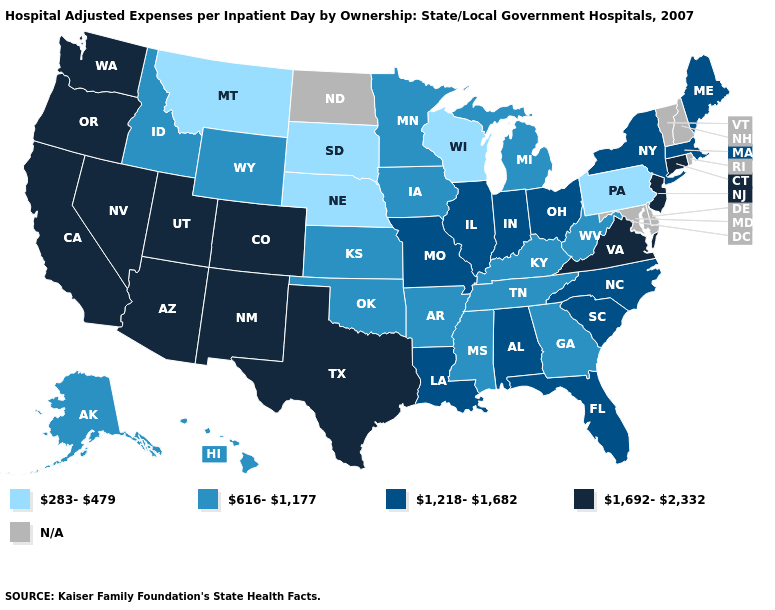Among the states that border West Virginia , does Virginia have the lowest value?
Be succinct. No. Which states have the highest value in the USA?
Give a very brief answer. Arizona, California, Colorado, Connecticut, Nevada, New Jersey, New Mexico, Oregon, Texas, Utah, Virginia, Washington. Does the first symbol in the legend represent the smallest category?
Concise answer only. Yes. Which states hav the highest value in the Northeast?
Answer briefly. Connecticut, New Jersey. Name the states that have a value in the range 616-1,177?
Short answer required. Alaska, Arkansas, Georgia, Hawaii, Idaho, Iowa, Kansas, Kentucky, Michigan, Minnesota, Mississippi, Oklahoma, Tennessee, West Virginia, Wyoming. Which states hav the highest value in the West?
Write a very short answer. Arizona, California, Colorado, Nevada, New Mexico, Oregon, Utah, Washington. Name the states that have a value in the range 1,692-2,332?
Short answer required. Arizona, California, Colorado, Connecticut, Nevada, New Jersey, New Mexico, Oregon, Texas, Utah, Virginia, Washington. Among the states that border New Mexico , which have the highest value?
Give a very brief answer. Arizona, Colorado, Texas, Utah. Which states have the highest value in the USA?
Quick response, please. Arizona, California, Colorado, Connecticut, Nevada, New Jersey, New Mexico, Oregon, Texas, Utah, Virginia, Washington. What is the highest value in the USA?
Quick response, please. 1,692-2,332. What is the value of Wisconsin?
Short answer required. 283-479. Name the states that have a value in the range 1,692-2,332?
Keep it brief. Arizona, California, Colorado, Connecticut, Nevada, New Jersey, New Mexico, Oregon, Texas, Utah, Virginia, Washington. Name the states that have a value in the range N/A?
Short answer required. Delaware, Maryland, New Hampshire, North Dakota, Rhode Island, Vermont. Name the states that have a value in the range 1,692-2,332?
Concise answer only. Arizona, California, Colorado, Connecticut, Nevada, New Jersey, New Mexico, Oregon, Texas, Utah, Virginia, Washington. 